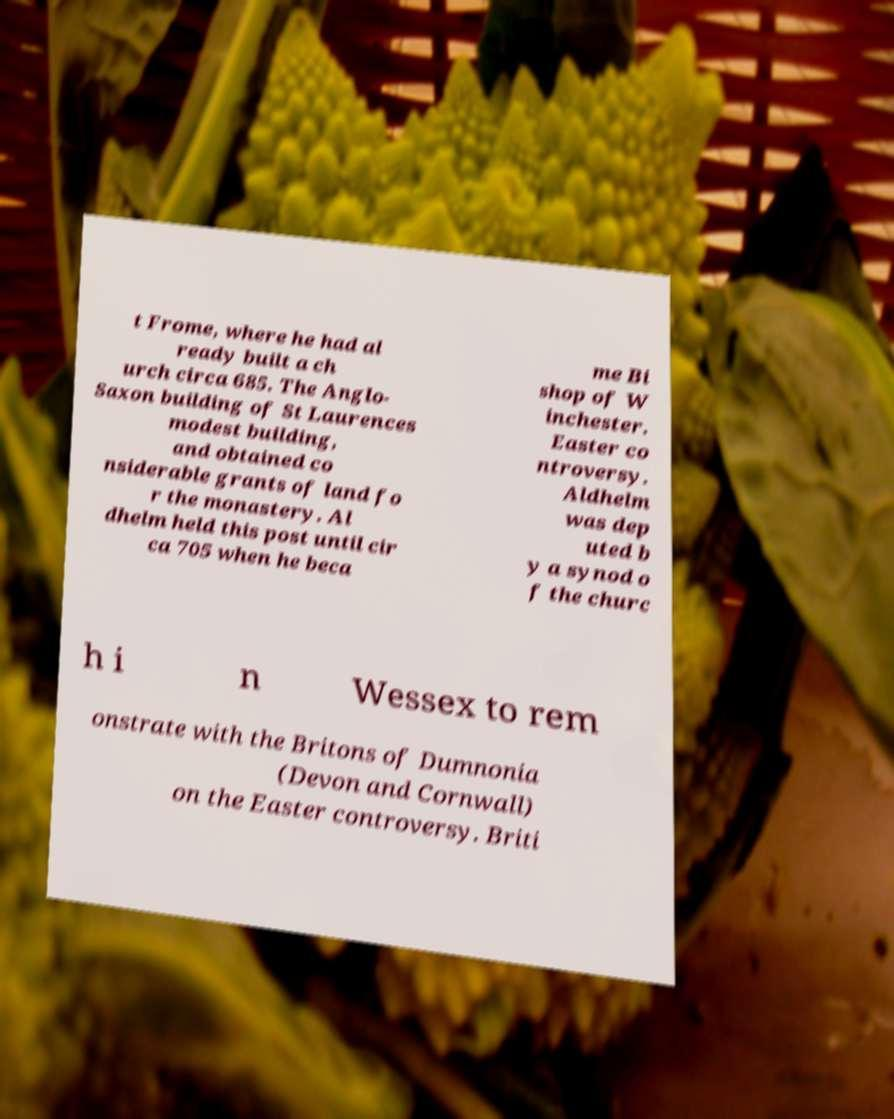Please read and relay the text visible in this image. What does it say? t Frome, where he had al ready built a ch urch circa 685. The Anglo- Saxon building of St Laurences modest building, and obtained co nsiderable grants of land fo r the monastery. Al dhelm held this post until cir ca 705 when he beca me Bi shop of W inchester. Easter co ntroversy. Aldhelm was dep uted b y a synod o f the churc h i n Wessex to rem onstrate with the Britons of Dumnonia (Devon and Cornwall) on the Easter controversy. Briti 